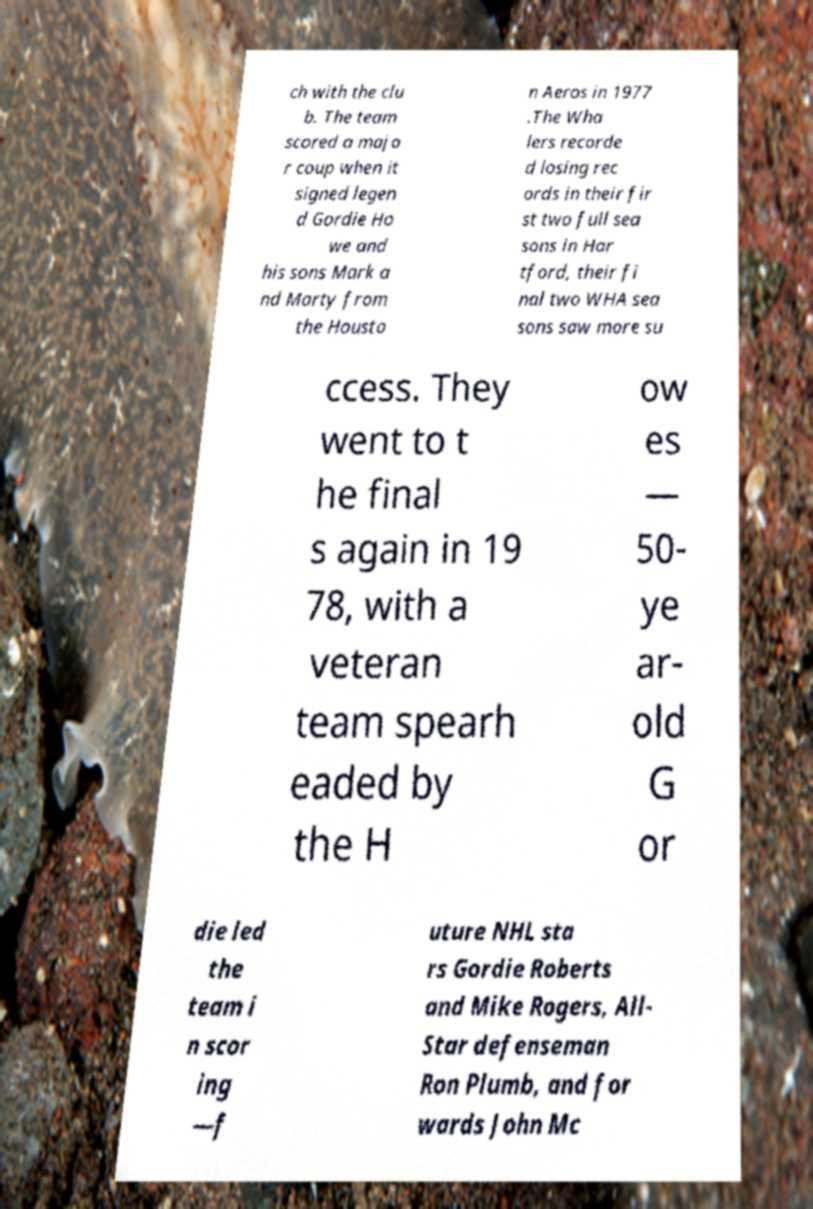Can you read and provide the text displayed in the image?This photo seems to have some interesting text. Can you extract and type it out for me? ch with the clu b. The team scored a majo r coup when it signed legen d Gordie Ho we and his sons Mark a nd Marty from the Housto n Aeros in 1977 .The Wha lers recorde d losing rec ords in their fir st two full sea sons in Har tford, their fi nal two WHA sea sons saw more su ccess. They went to t he final s again in 19 78, with a veteran team spearh eaded by the H ow es — 50- ye ar- old G or die led the team i n scor ing —f uture NHL sta rs Gordie Roberts and Mike Rogers, All- Star defenseman Ron Plumb, and for wards John Mc 